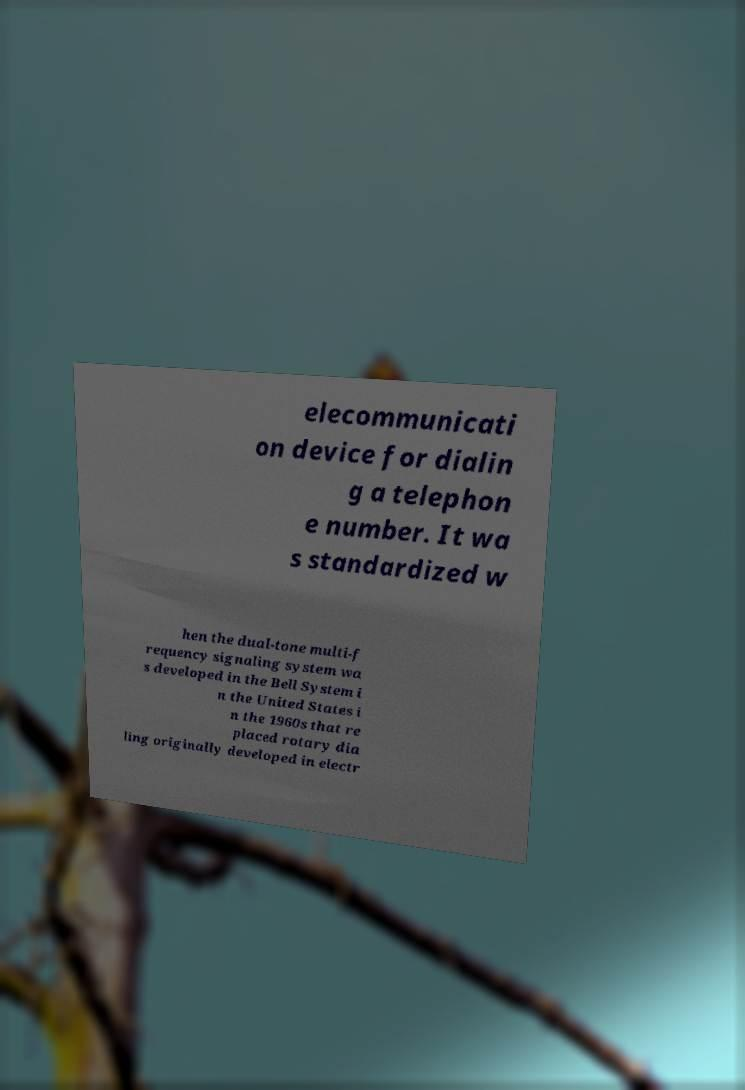Please read and relay the text visible in this image. What does it say? elecommunicati on device for dialin g a telephon e number. It wa s standardized w hen the dual-tone multi-f requency signaling system wa s developed in the Bell System i n the United States i n the 1960s that re placed rotary dia ling originally developed in electr 